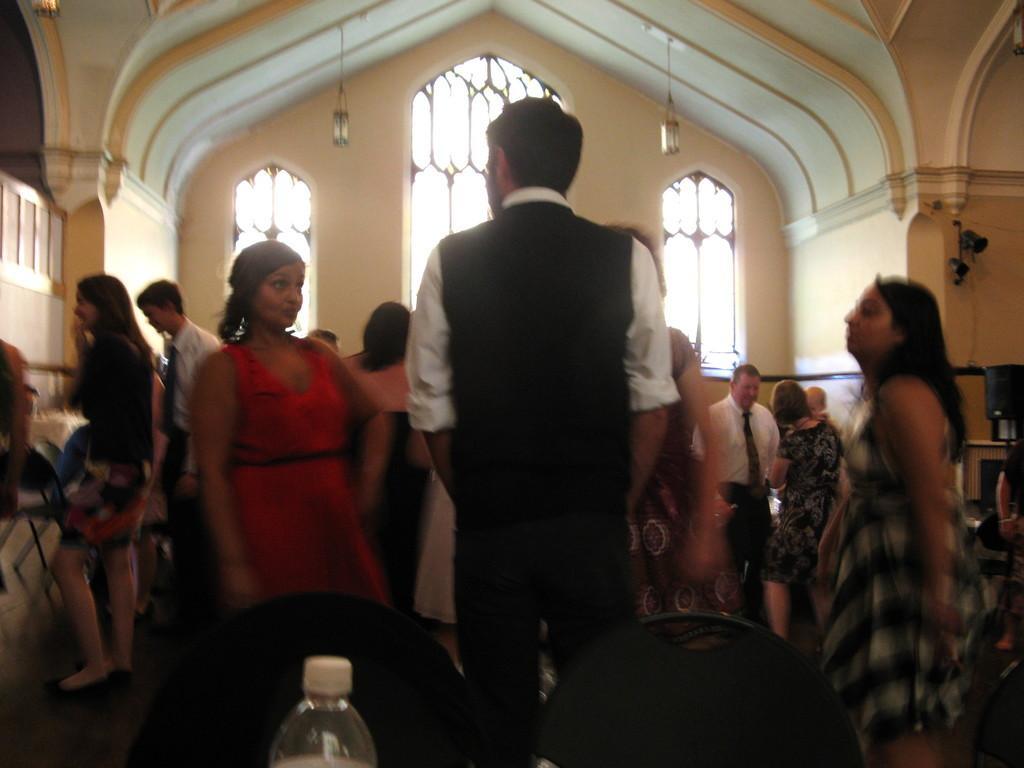Describe this image in one or two sentences. In this picture there are a group of people standing and in the background there is a window and lamps. 